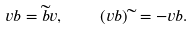Convert formula to latex. <formula><loc_0><loc_0><loc_500><loc_500>v b = \widetilde { b } v , \quad ( v b ) \widetilde { \ } = - v b .</formula> 